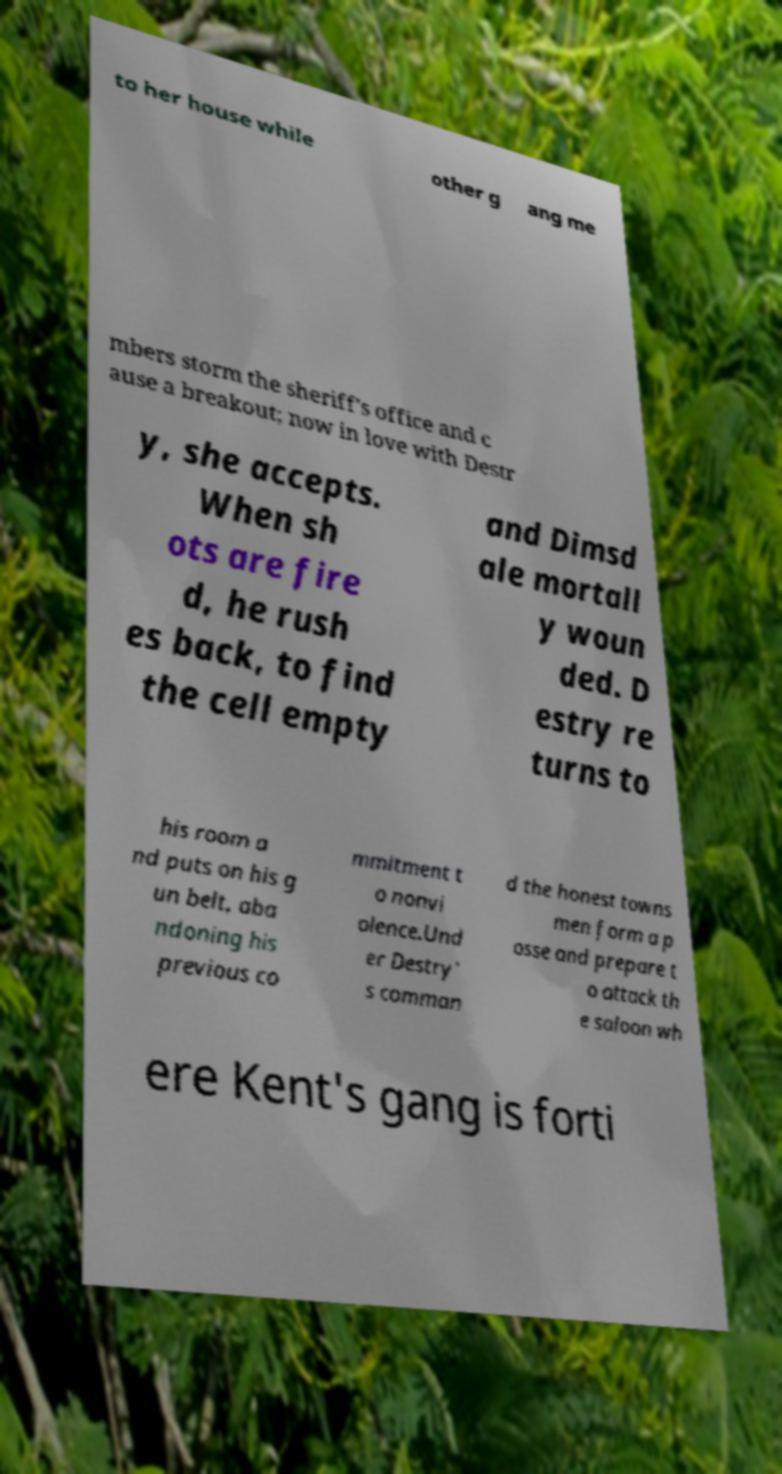What messages or text are displayed in this image? I need them in a readable, typed format. to her house while other g ang me mbers storm the sheriff's office and c ause a breakout; now in love with Destr y, she accepts. When sh ots are fire d, he rush es back, to find the cell empty and Dimsd ale mortall y woun ded. D estry re turns to his room a nd puts on his g un belt, aba ndoning his previous co mmitment t o nonvi olence.Und er Destry' s comman d the honest towns men form a p osse and prepare t o attack th e saloon wh ere Kent's gang is forti 